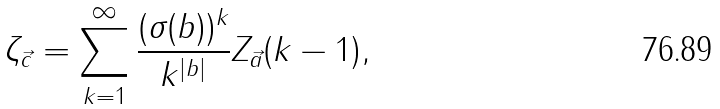Convert formula to latex. <formula><loc_0><loc_0><loc_500><loc_500>\zeta _ { \vec { c } } = \sum _ { k = 1 } ^ { \infty } \frac { ( { \sigma } ( b ) ) ^ { k } } { k ^ { | b | } } Z _ { \vec { a } } ( k - 1 ) ,</formula> 